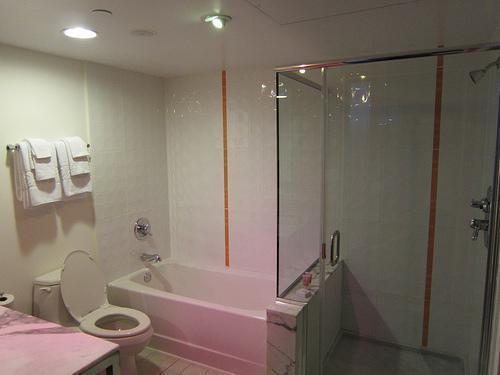How many towels are there?
Give a very brief answer. 6. How many gold stripes are on the walls?
Give a very brief answer. 2. How many orange stripes go towards the bath?
Give a very brief answer. 1. 